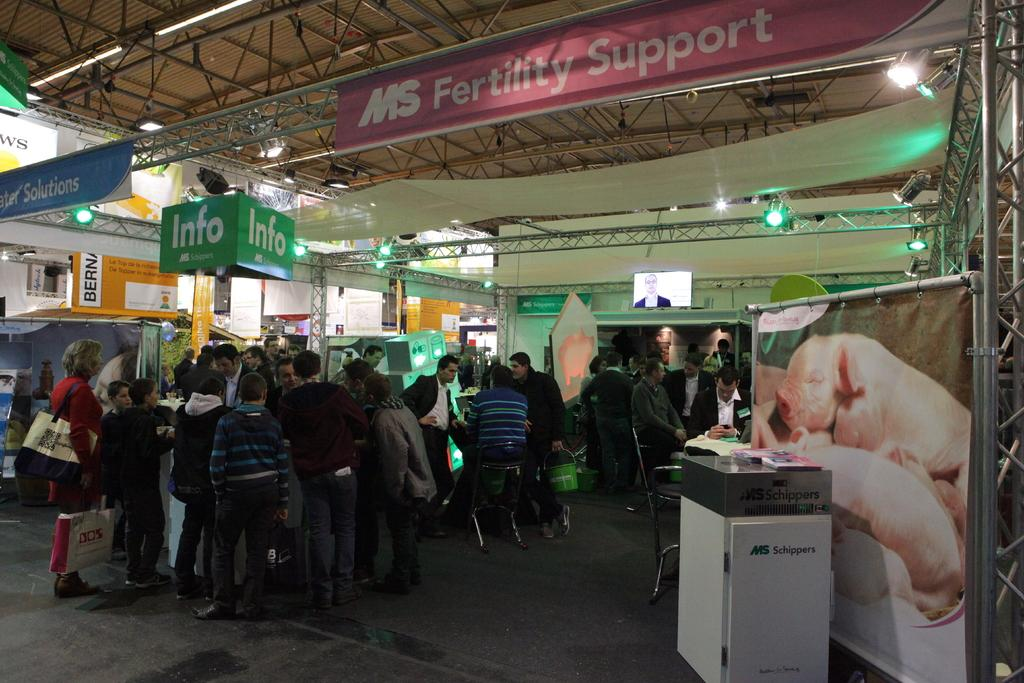Provide a one-sentence caption for the provided image. An area in a building labeled MS Fertility Support. 